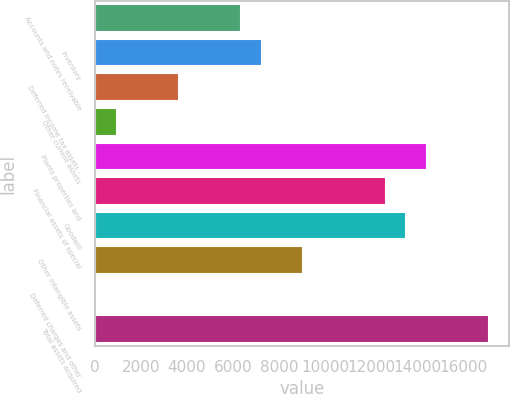<chart> <loc_0><loc_0><loc_500><loc_500><bar_chart><fcel>Accounts and notes receivable<fcel>Inventory<fcel>Deferred income tax assets -<fcel>Other current assets<fcel>Plants properties and<fcel>Financial assets of special<fcel>Goodwill<fcel>Other intangible assets<fcel>Deferred charges and other<fcel>Total assets acquired<nl><fcel>6340.7<fcel>7238.8<fcel>3646.4<fcel>952.1<fcel>14423.6<fcel>12627.4<fcel>13525.5<fcel>9035<fcel>54<fcel>17117.9<nl></chart> 